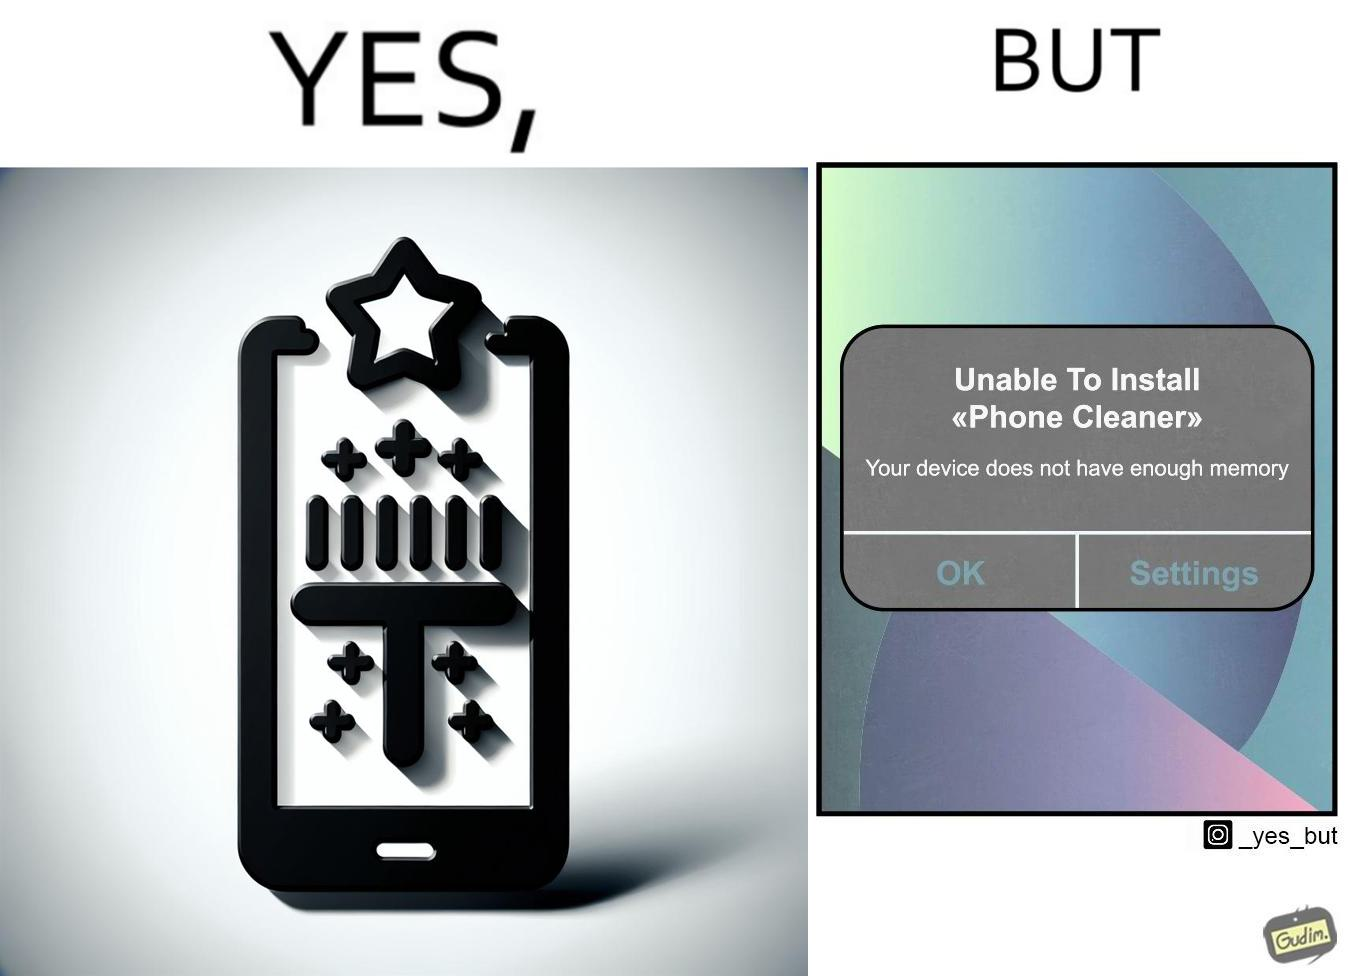Describe the satirical element in this image. The image is ironical, as to clear the phone's memory using phone cleaner app, one has to install it, but that is not possible in turn due to the phone memory being full. 